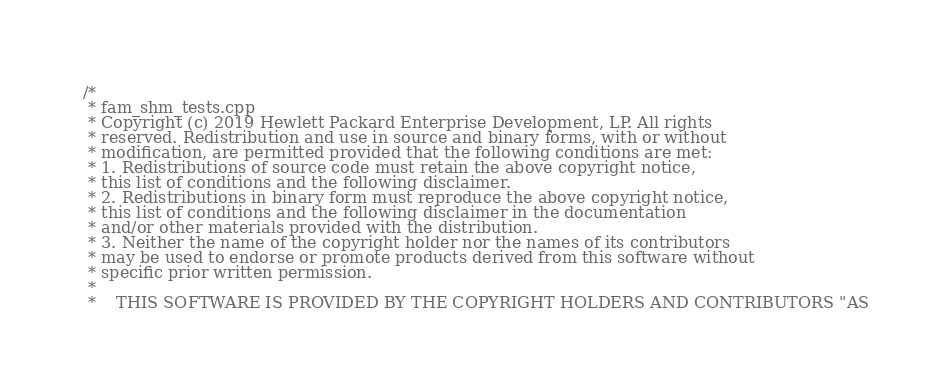Convert code to text. <code><loc_0><loc_0><loc_500><loc_500><_C++_>/*
 * fam_shm_tests.cpp
 * Copyright (c) 2019 Hewlett Packard Enterprise Development, LP. All rights
 * reserved. Redistribution and use in source and binary forms, with or without
 * modification, are permitted provided that the following conditions are met:
 * 1. Redistributions of source code must retain the above copyright notice,
 * this list of conditions and the following disclaimer.
 * 2. Redistributions in binary form must reproduce the above copyright notice,
 * this list of conditions and the following disclaimer in the documentation
 * and/or other materials provided with the distribution.
 * 3. Neither the name of the copyright holder nor the names of its contributors
 * may be used to endorse or promote products derived from this software without
 * specific prior written permission.
 *
 *    THIS SOFTWARE IS PROVIDED BY THE COPYRIGHT HOLDERS AND CONTRIBUTORS "AS</code> 